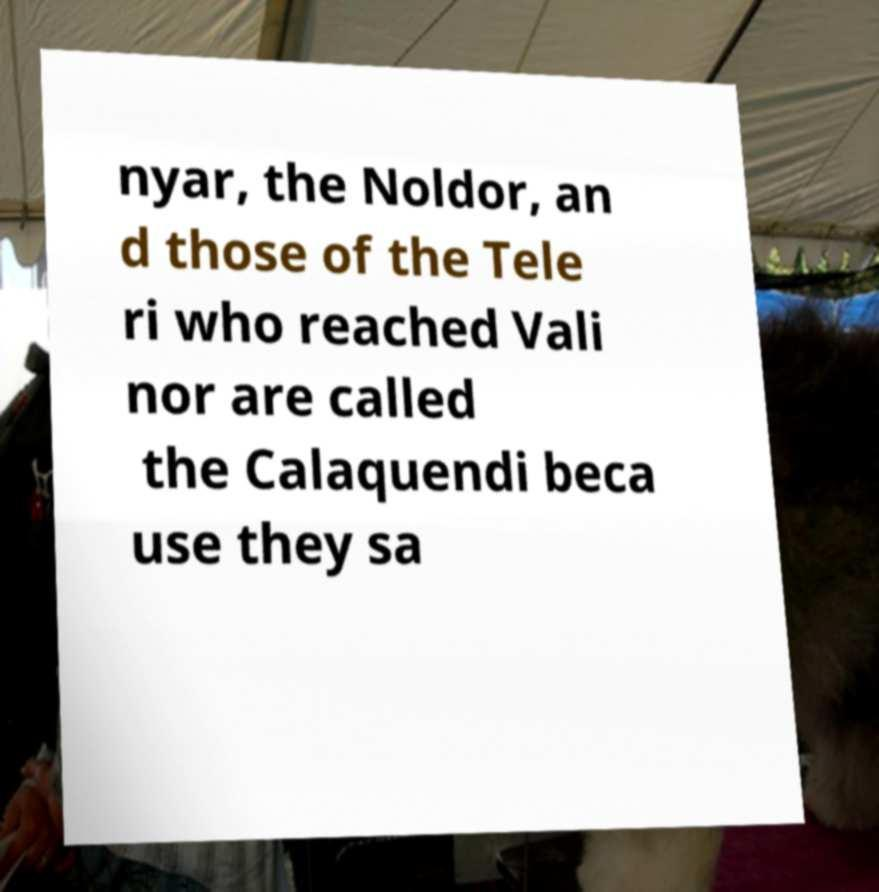For documentation purposes, I need the text within this image transcribed. Could you provide that? nyar, the Noldor, an d those of the Tele ri who reached Vali nor are called the Calaquendi beca use they sa 